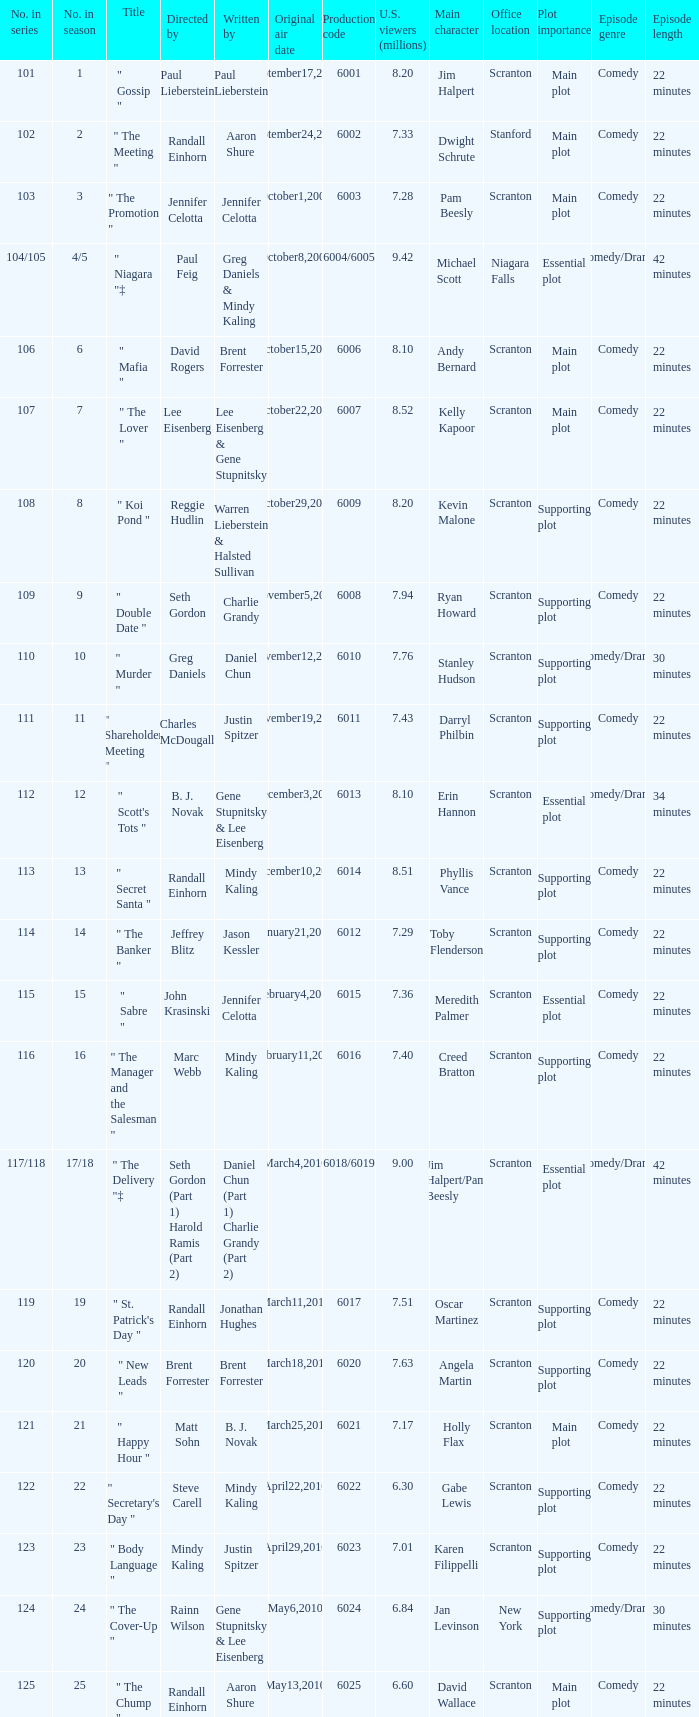Name the production code for number in season being 21 6021.0. 